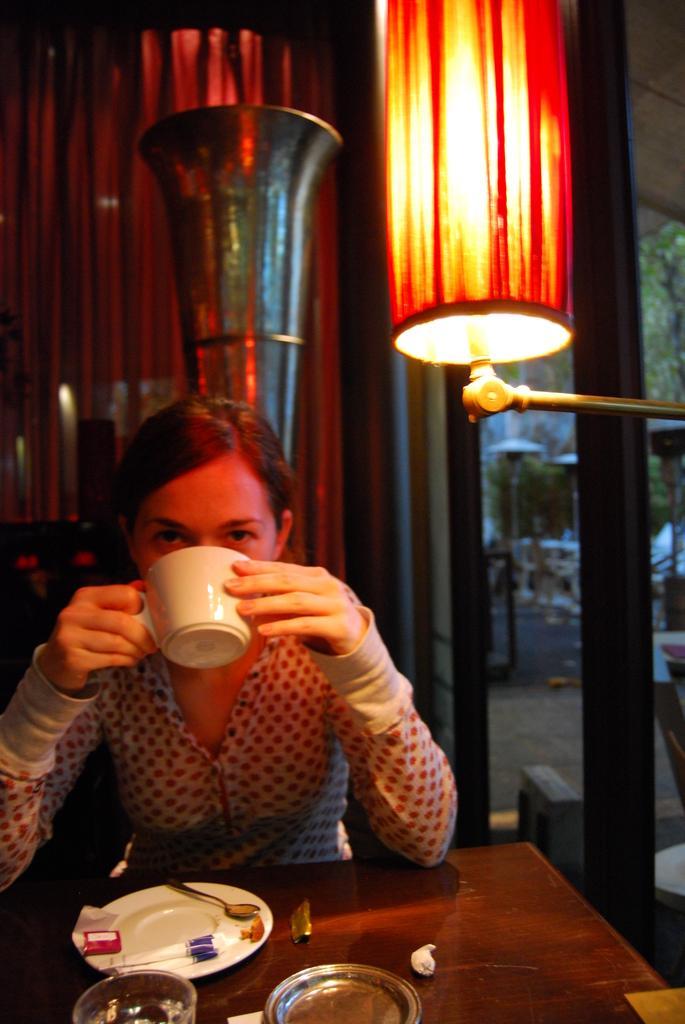Could you give a brief overview of what you see in this image? In this image, we can see a woman sitting and drinking something, there is a table, on that table, we can see a plate, we can see a light and there are some windows. 